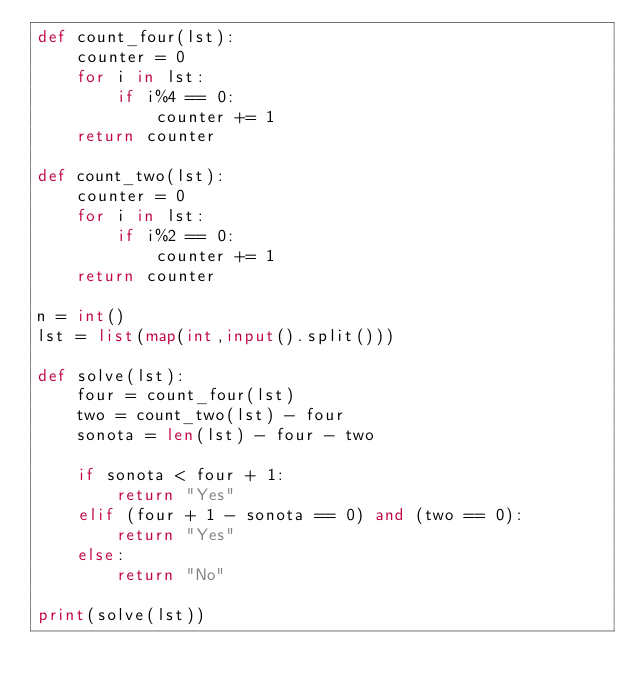<code> <loc_0><loc_0><loc_500><loc_500><_Python_>def count_four(lst):
    counter = 0
    for i in lst:
        if i%4 == 0:
            counter += 1
    return counter

def count_two(lst):
    counter = 0
    for i in lst:
        if i%2 == 0:
            counter += 1
    return counter

n = int()
lst = list(map(int,input().split()))

def solve(lst):
    four = count_four(lst)
    two = count_two(lst) - four
    sonota = len(lst) - four - two

    if sonota < four + 1:
        return "Yes"
    elif (four + 1 - sonota == 0) and (two == 0):
        return "Yes"
    else:
        return "No"

print(solve(lst))

</code> 